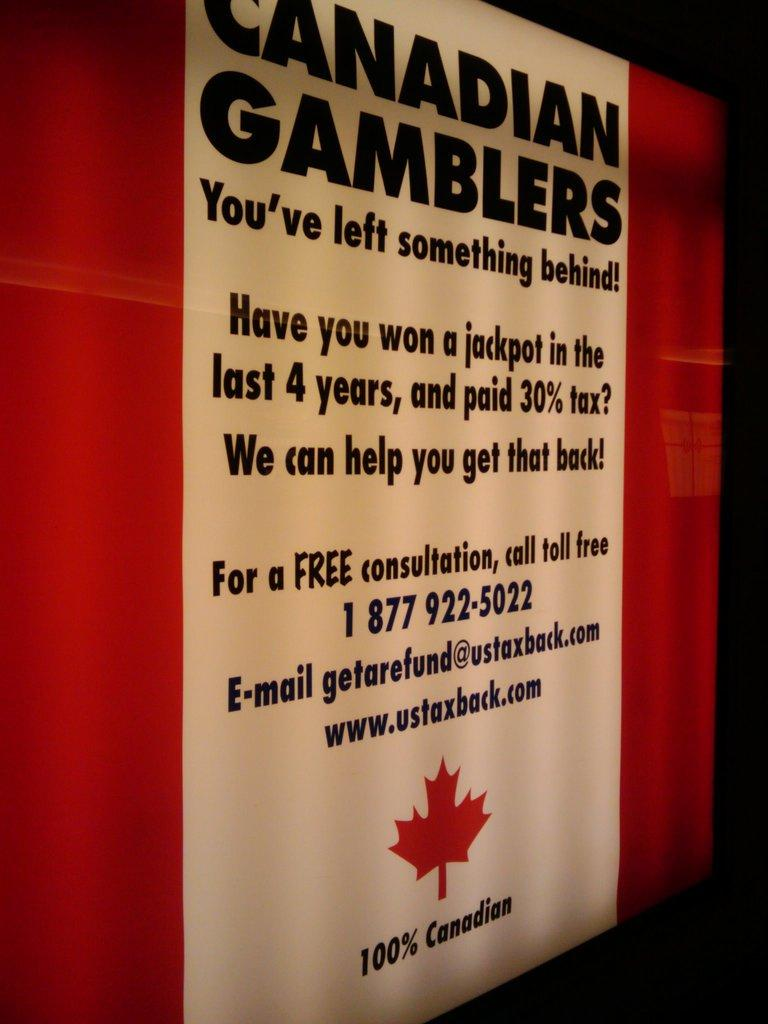Provide a one-sentence caption for the provided image. A sign that says "Canadian Gamblers You've left something behind!" and includes information about a free tax consultation is shown. 